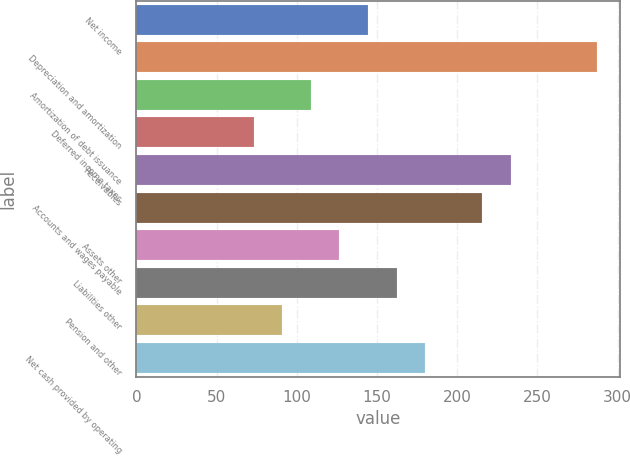<chart> <loc_0><loc_0><loc_500><loc_500><bar_chart><fcel>Net income<fcel>Depreciation and amortization<fcel>Amortization of debt issuance<fcel>Deferred income taxes<fcel>Receivables<fcel>Accounts and wages payable<fcel>Assets other<fcel>Liabilities other<fcel>Pension and other<fcel>Net cash provided by operating<nl><fcel>144.4<fcel>286.8<fcel>108.8<fcel>73.2<fcel>233.4<fcel>215.6<fcel>126.6<fcel>162.2<fcel>91<fcel>180<nl></chart> 